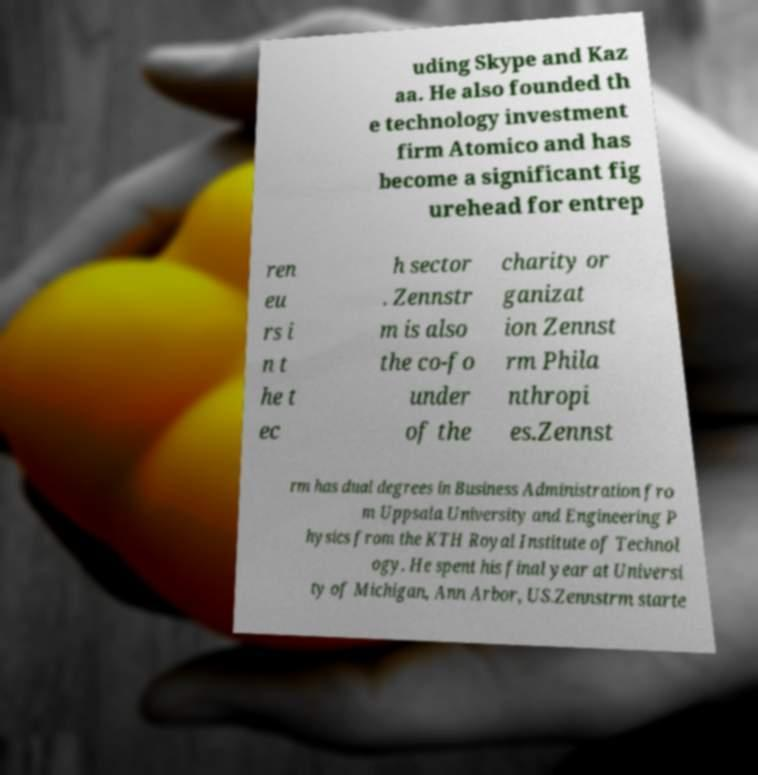Could you assist in decoding the text presented in this image and type it out clearly? uding Skype and Kaz aa. He also founded th e technology investment firm Atomico and has become a significant fig urehead for entrep ren eu rs i n t he t ec h sector . Zennstr m is also the co-fo under of the charity or ganizat ion Zennst rm Phila nthropi es.Zennst rm has dual degrees in Business Administration fro m Uppsala University and Engineering P hysics from the KTH Royal Institute of Technol ogy. He spent his final year at Universi ty of Michigan, Ann Arbor, US.Zennstrm starte 